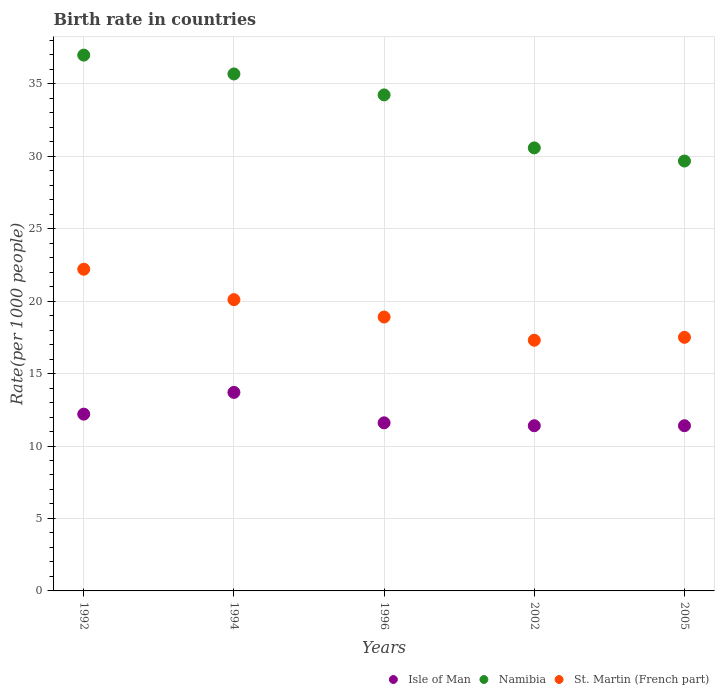Is the number of dotlines equal to the number of legend labels?
Keep it short and to the point. Yes. What is the birth rate in Namibia in 1994?
Your response must be concise. 35.67. Across all years, what is the maximum birth rate in Namibia?
Your answer should be very brief. 36.98. Across all years, what is the minimum birth rate in Namibia?
Keep it short and to the point. 29.67. What is the total birth rate in Isle of Man in the graph?
Provide a short and direct response. 60.3. What is the difference between the birth rate in Isle of Man in 1994 and that in 1996?
Offer a terse response. 2.1. What is the difference between the birth rate in Namibia in 2005 and the birth rate in St. Martin (French part) in 1996?
Your answer should be very brief. 10.77. What is the average birth rate in Isle of Man per year?
Make the answer very short. 12.06. In the year 1996, what is the difference between the birth rate in Isle of Man and birth rate in Namibia?
Ensure brevity in your answer.  -22.63. In how many years, is the birth rate in Namibia greater than 18?
Give a very brief answer. 5. What is the ratio of the birth rate in St. Martin (French part) in 1992 to that in 1996?
Give a very brief answer. 1.17. Is the birth rate in Namibia in 1994 less than that in 2005?
Give a very brief answer. No. Is the difference between the birth rate in Isle of Man in 1996 and 2005 greater than the difference between the birth rate in Namibia in 1996 and 2005?
Give a very brief answer. No. What is the difference between the highest and the second highest birth rate in St. Martin (French part)?
Offer a very short reply. 2.1. What is the difference between the highest and the lowest birth rate in St. Martin (French part)?
Keep it short and to the point. 4.9. Is it the case that in every year, the sum of the birth rate in St. Martin (French part) and birth rate in Namibia  is greater than the birth rate in Isle of Man?
Offer a terse response. Yes. Does the birth rate in St. Martin (French part) monotonically increase over the years?
Offer a very short reply. No. Is the birth rate in St. Martin (French part) strictly greater than the birth rate in Namibia over the years?
Your answer should be compact. No. How many years are there in the graph?
Make the answer very short. 5. What is the difference between two consecutive major ticks on the Y-axis?
Provide a short and direct response. 5. Are the values on the major ticks of Y-axis written in scientific E-notation?
Ensure brevity in your answer.  No. Where does the legend appear in the graph?
Make the answer very short. Bottom right. How many legend labels are there?
Offer a very short reply. 3. How are the legend labels stacked?
Keep it short and to the point. Horizontal. What is the title of the graph?
Your response must be concise. Birth rate in countries. What is the label or title of the Y-axis?
Give a very brief answer. Rate(per 1000 people). What is the Rate(per 1000 people) in Isle of Man in 1992?
Your answer should be compact. 12.2. What is the Rate(per 1000 people) of Namibia in 1992?
Ensure brevity in your answer.  36.98. What is the Rate(per 1000 people) in Isle of Man in 1994?
Offer a very short reply. 13.7. What is the Rate(per 1000 people) of Namibia in 1994?
Offer a very short reply. 35.67. What is the Rate(per 1000 people) of St. Martin (French part) in 1994?
Your answer should be compact. 20.1. What is the Rate(per 1000 people) in Namibia in 1996?
Your response must be concise. 34.23. What is the Rate(per 1000 people) of Isle of Man in 2002?
Give a very brief answer. 11.4. What is the Rate(per 1000 people) in Namibia in 2002?
Make the answer very short. 30.57. What is the Rate(per 1000 people) in Namibia in 2005?
Your response must be concise. 29.67. What is the Rate(per 1000 people) in St. Martin (French part) in 2005?
Provide a succinct answer. 17.5. Across all years, what is the maximum Rate(per 1000 people) in Namibia?
Provide a succinct answer. 36.98. Across all years, what is the minimum Rate(per 1000 people) of Isle of Man?
Your answer should be compact. 11.4. Across all years, what is the minimum Rate(per 1000 people) of Namibia?
Your answer should be compact. 29.67. What is the total Rate(per 1000 people) in Isle of Man in the graph?
Your answer should be compact. 60.3. What is the total Rate(per 1000 people) in Namibia in the graph?
Make the answer very short. 167.12. What is the total Rate(per 1000 people) in St. Martin (French part) in the graph?
Provide a succinct answer. 96. What is the difference between the Rate(per 1000 people) of Namibia in 1992 and that in 1994?
Offer a terse response. 1.3. What is the difference between the Rate(per 1000 people) of Namibia in 1992 and that in 1996?
Offer a terse response. 2.75. What is the difference between the Rate(per 1000 people) in Namibia in 1992 and that in 2002?
Provide a succinct answer. 6.4. What is the difference between the Rate(per 1000 people) in Isle of Man in 1992 and that in 2005?
Make the answer very short. 0.8. What is the difference between the Rate(per 1000 people) in Namibia in 1992 and that in 2005?
Your response must be concise. 7.31. What is the difference between the Rate(per 1000 people) in St. Martin (French part) in 1992 and that in 2005?
Give a very brief answer. 4.7. What is the difference between the Rate(per 1000 people) of Isle of Man in 1994 and that in 1996?
Provide a short and direct response. 2.1. What is the difference between the Rate(per 1000 people) of Namibia in 1994 and that in 1996?
Your response must be concise. 1.45. What is the difference between the Rate(per 1000 people) of Namibia in 1994 and that in 2002?
Ensure brevity in your answer.  5.1. What is the difference between the Rate(per 1000 people) of Isle of Man in 1994 and that in 2005?
Your response must be concise. 2.3. What is the difference between the Rate(per 1000 people) of Namibia in 1994 and that in 2005?
Give a very brief answer. 6.01. What is the difference between the Rate(per 1000 people) of St. Martin (French part) in 1994 and that in 2005?
Your response must be concise. 2.6. What is the difference between the Rate(per 1000 people) of Isle of Man in 1996 and that in 2002?
Provide a short and direct response. 0.2. What is the difference between the Rate(per 1000 people) in Namibia in 1996 and that in 2002?
Offer a very short reply. 3.66. What is the difference between the Rate(per 1000 people) of St. Martin (French part) in 1996 and that in 2002?
Your answer should be compact. 1.6. What is the difference between the Rate(per 1000 people) in Isle of Man in 1996 and that in 2005?
Offer a very short reply. 0.2. What is the difference between the Rate(per 1000 people) of Namibia in 1996 and that in 2005?
Give a very brief answer. 4.56. What is the difference between the Rate(per 1000 people) in St. Martin (French part) in 1996 and that in 2005?
Your answer should be compact. 1.4. What is the difference between the Rate(per 1000 people) in Isle of Man in 2002 and that in 2005?
Give a very brief answer. 0. What is the difference between the Rate(per 1000 people) of Namibia in 2002 and that in 2005?
Your response must be concise. 0.91. What is the difference between the Rate(per 1000 people) of St. Martin (French part) in 2002 and that in 2005?
Give a very brief answer. -0.2. What is the difference between the Rate(per 1000 people) in Isle of Man in 1992 and the Rate(per 1000 people) in Namibia in 1994?
Provide a succinct answer. -23.48. What is the difference between the Rate(per 1000 people) in Namibia in 1992 and the Rate(per 1000 people) in St. Martin (French part) in 1994?
Provide a short and direct response. 16.88. What is the difference between the Rate(per 1000 people) in Isle of Man in 1992 and the Rate(per 1000 people) in Namibia in 1996?
Make the answer very short. -22.03. What is the difference between the Rate(per 1000 people) in Namibia in 1992 and the Rate(per 1000 people) in St. Martin (French part) in 1996?
Your answer should be compact. 18.08. What is the difference between the Rate(per 1000 people) of Isle of Man in 1992 and the Rate(per 1000 people) of Namibia in 2002?
Offer a terse response. -18.37. What is the difference between the Rate(per 1000 people) of Namibia in 1992 and the Rate(per 1000 people) of St. Martin (French part) in 2002?
Make the answer very short. 19.68. What is the difference between the Rate(per 1000 people) in Isle of Man in 1992 and the Rate(per 1000 people) in Namibia in 2005?
Your answer should be very brief. -17.47. What is the difference between the Rate(per 1000 people) in Isle of Man in 1992 and the Rate(per 1000 people) in St. Martin (French part) in 2005?
Offer a terse response. -5.3. What is the difference between the Rate(per 1000 people) of Namibia in 1992 and the Rate(per 1000 people) of St. Martin (French part) in 2005?
Make the answer very short. 19.48. What is the difference between the Rate(per 1000 people) in Isle of Man in 1994 and the Rate(per 1000 people) in Namibia in 1996?
Your answer should be compact. -20.53. What is the difference between the Rate(per 1000 people) in Isle of Man in 1994 and the Rate(per 1000 people) in St. Martin (French part) in 1996?
Your answer should be compact. -5.2. What is the difference between the Rate(per 1000 people) of Namibia in 1994 and the Rate(per 1000 people) of St. Martin (French part) in 1996?
Provide a succinct answer. 16.77. What is the difference between the Rate(per 1000 people) of Isle of Man in 1994 and the Rate(per 1000 people) of Namibia in 2002?
Offer a terse response. -16.87. What is the difference between the Rate(per 1000 people) of Namibia in 1994 and the Rate(per 1000 people) of St. Martin (French part) in 2002?
Give a very brief answer. 18.38. What is the difference between the Rate(per 1000 people) in Isle of Man in 1994 and the Rate(per 1000 people) in Namibia in 2005?
Your answer should be compact. -15.97. What is the difference between the Rate(per 1000 people) of Namibia in 1994 and the Rate(per 1000 people) of St. Martin (French part) in 2005?
Your answer should be very brief. 18.18. What is the difference between the Rate(per 1000 people) of Isle of Man in 1996 and the Rate(per 1000 people) of Namibia in 2002?
Your answer should be very brief. -18.97. What is the difference between the Rate(per 1000 people) in Namibia in 1996 and the Rate(per 1000 people) in St. Martin (French part) in 2002?
Your answer should be very brief. 16.93. What is the difference between the Rate(per 1000 people) in Isle of Man in 1996 and the Rate(per 1000 people) in Namibia in 2005?
Your response must be concise. -18.07. What is the difference between the Rate(per 1000 people) in Isle of Man in 1996 and the Rate(per 1000 people) in St. Martin (French part) in 2005?
Give a very brief answer. -5.9. What is the difference between the Rate(per 1000 people) of Namibia in 1996 and the Rate(per 1000 people) of St. Martin (French part) in 2005?
Offer a very short reply. 16.73. What is the difference between the Rate(per 1000 people) of Isle of Man in 2002 and the Rate(per 1000 people) of Namibia in 2005?
Keep it short and to the point. -18.27. What is the difference between the Rate(per 1000 people) in Namibia in 2002 and the Rate(per 1000 people) in St. Martin (French part) in 2005?
Keep it short and to the point. 13.07. What is the average Rate(per 1000 people) in Isle of Man per year?
Offer a very short reply. 12.06. What is the average Rate(per 1000 people) of Namibia per year?
Offer a terse response. 33.42. What is the average Rate(per 1000 people) of St. Martin (French part) per year?
Give a very brief answer. 19.2. In the year 1992, what is the difference between the Rate(per 1000 people) of Isle of Man and Rate(per 1000 people) of Namibia?
Provide a short and direct response. -24.78. In the year 1992, what is the difference between the Rate(per 1000 people) of Isle of Man and Rate(per 1000 people) of St. Martin (French part)?
Make the answer very short. -10. In the year 1992, what is the difference between the Rate(per 1000 people) of Namibia and Rate(per 1000 people) of St. Martin (French part)?
Your answer should be very brief. 14.78. In the year 1994, what is the difference between the Rate(per 1000 people) of Isle of Man and Rate(per 1000 people) of Namibia?
Offer a terse response. -21.98. In the year 1994, what is the difference between the Rate(per 1000 people) in Namibia and Rate(per 1000 people) in St. Martin (French part)?
Make the answer very short. 15.57. In the year 1996, what is the difference between the Rate(per 1000 people) of Isle of Man and Rate(per 1000 people) of Namibia?
Your answer should be very brief. -22.63. In the year 1996, what is the difference between the Rate(per 1000 people) of Namibia and Rate(per 1000 people) of St. Martin (French part)?
Ensure brevity in your answer.  15.33. In the year 2002, what is the difference between the Rate(per 1000 people) of Isle of Man and Rate(per 1000 people) of Namibia?
Keep it short and to the point. -19.17. In the year 2002, what is the difference between the Rate(per 1000 people) of Isle of Man and Rate(per 1000 people) of St. Martin (French part)?
Give a very brief answer. -5.9. In the year 2002, what is the difference between the Rate(per 1000 people) in Namibia and Rate(per 1000 people) in St. Martin (French part)?
Offer a very short reply. 13.27. In the year 2005, what is the difference between the Rate(per 1000 people) in Isle of Man and Rate(per 1000 people) in Namibia?
Your response must be concise. -18.27. In the year 2005, what is the difference between the Rate(per 1000 people) of Isle of Man and Rate(per 1000 people) of St. Martin (French part)?
Keep it short and to the point. -6.1. In the year 2005, what is the difference between the Rate(per 1000 people) in Namibia and Rate(per 1000 people) in St. Martin (French part)?
Your answer should be very brief. 12.17. What is the ratio of the Rate(per 1000 people) in Isle of Man in 1992 to that in 1994?
Ensure brevity in your answer.  0.89. What is the ratio of the Rate(per 1000 people) of Namibia in 1992 to that in 1994?
Provide a short and direct response. 1.04. What is the ratio of the Rate(per 1000 people) of St. Martin (French part) in 1992 to that in 1994?
Provide a succinct answer. 1.1. What is the ratio of the Rate(per 1000 people) in Isle of Man in 1992 to that in 1996?
Offer a terse response. 1.05. What is the ratio of the Rate(per 1000 people) of Namibia in 1992 to that in 1996?
Offer a very short reply. 1.08. What is the ratio of the Rate(per 1000 people) in St. Martin (French part) in 1992 to that in 1996?
Offer a terse response. 1.17. What is the ratio of the Rate(per 1000 people) in Isle of Man in 1992 to that in 2002?
Provide a short and direct response. 1.07. What is the ratio of the Rate(per 1000 people) in Namibia in 1992 to that in 2002?
Offer a very short reply. 1.21. What is the ratio of the Rate(per 1000 people) of St. Martin (French part) in 1992 to that in 2002?
Your response must be concise. 1.28. What is the ratio of the Rate(per 1000 people) in Isle of Man in 1992 to that in 2005?
Your answer should be compact. 1.07. What is the ratio of the Rate(per 1000 people) of Namibia in 1992 to that in 2005?
Your answer should be compact. 1.25. What is the ratio of the Rate(per 1000 people) in St. Martin (French part) in 1992 to that in 2005?
Your answer should be compact. 1.27. What is the ratio of the Rate(per 1000 people) of Isle of Man in 1994 to that in 1996?
Your response must be concise. 1.18. What is the ratio of the Rate(per 1000 people) of Namibia in 1994 to that in 1996?
Give a very brief answer. 1.04. What is the ratio of the Rate(per 1000 people) of St. Martin (French part) in 1994 to that in 1996?
Make the answer very short. 1.06. What is the ratio of the Rate(per 1000 people) in Isle of Man in 1994 to that in 2002?
Your response must be concise. 1.2. What is the ratio of the Rate(per 1000 people) of Namibia in 1994 to that in 2002?
Your answer should be compact. 1.17. What is the ratio of the Rate(per 1000 people) of St. Martin (French part) in 1994 to that in 2002?
Your response must be concise. 1.16. What is the ratio of the Rate(per 1000 people) of Isle of Man in 1994 to that in 2005?
Your answer should be compact. 1.2. What is the ratio of the Rate(per 1000 people) of Namibia in 1994 to that in 2005?
Ensure brevity in your answer.  1.2. What is the ratio of the Rate(per 1000 people) in St. Martin (French part) in 1994 to that in 2005?
Keep it short and to the point. 1.15. What is the ratio of the Rate(per 1000 people) in Isle of Man in 1996 to that in 2002?
Give a very brief answer. 1.02. What is the ratio of the Rate(per 1000 people) of Namibia in 1996 to that in 2002?
Ensure brevity in your answer.  1.12. What is the ratio of the Rate(per 1000 people) of St. Martin (French part) in 1996 to that in 2002?
Your answer should be compact. 1.09. What is the ratio of the Rate(per 1000 people) in Isle of Man in 1996 to that in 2005?
Ensure brevity in your answer.  1.02. What is the ratio of the Rate(per 1000 people) of Namibia in 1996 to that in 2005?
Your answer should be compact. 1.15. What is the ratio of the Rate(per 1000 people) of St. Martin (French part) in 1996 to that in 2005?
Ensure brevity in your answer.  1.08. What is the ratio of the Rate(per 1000 people) of Isle of Man in 2002 to that in 2005?
Make the answer very short. 1. What is the ratio of the Rate(per 1000 people) in Namibia in 2002 to that in 2005?
Provide a succinct answer. 1.03. What is the difference between the highest and the second highest Rate(per 1000 people) in Namibia?
Provide a short and direct response. 1.3. What is the difference between the highest and the second highest Rate(per 1000 people) in St. Martin (French part)?
Make the answer very short. 2.1. What is the difference between the highest and the lowest Rate(per 1000 people) of Namibia?
Offer a terse response. 7.31. What is the difference between the highest and the lowest Rate(per 1000 people) in St. Martin (French part)?
Keep it short and to the point. 4.9. 